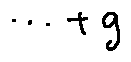<formula> <loc_0><loc_0><loc_500><loc_500>\cdots + g</formula> 